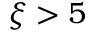Convert formula to latex. <formula><loc_0><loc_0><loc_500><loc_500>\xi > 5</formula> 